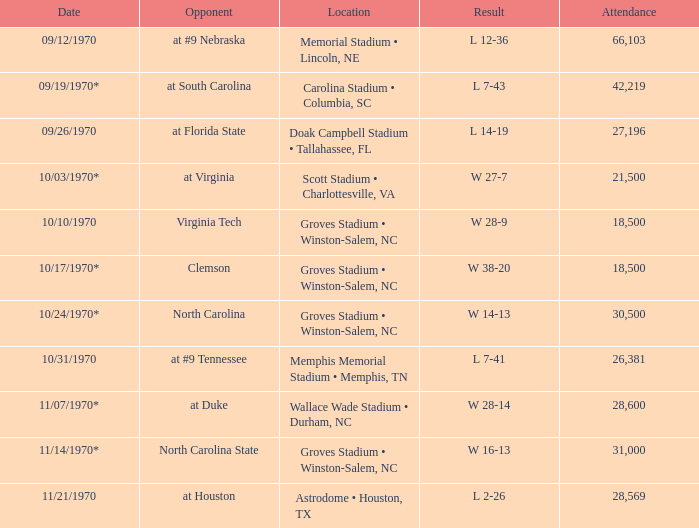How many people attended the game against Clemson? 1.0. 